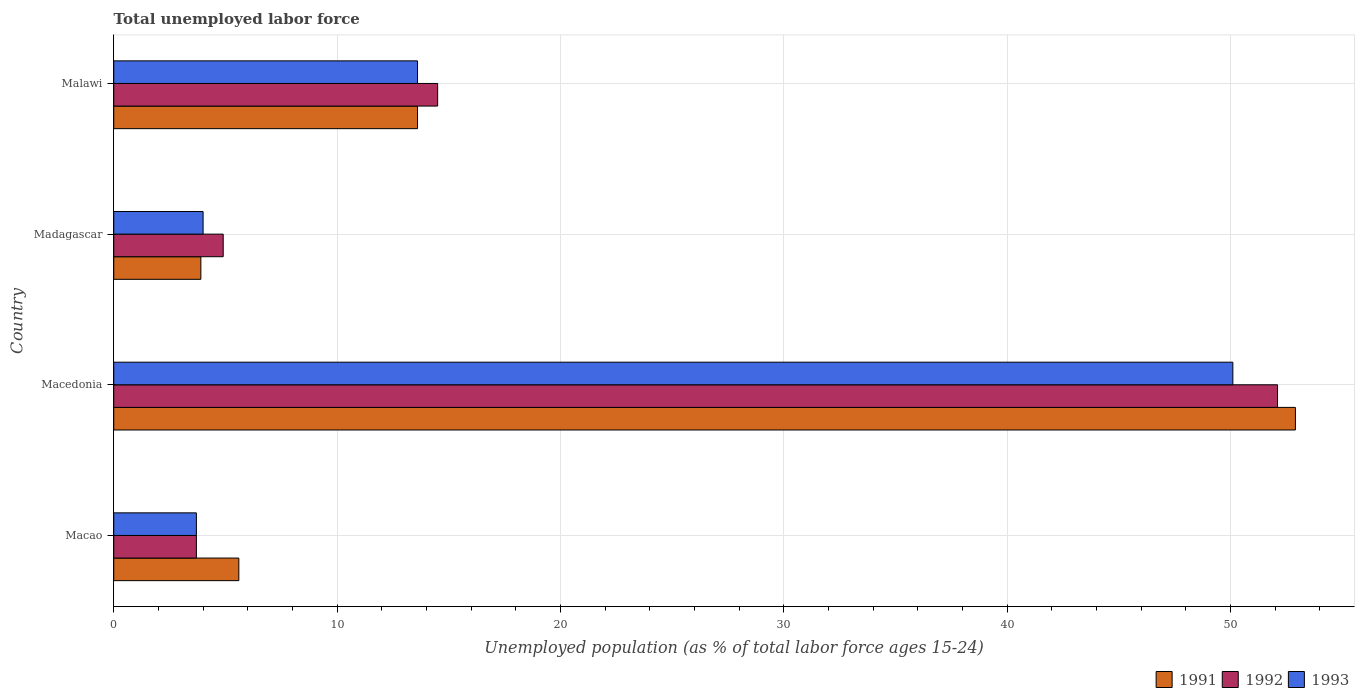How many groups of bars are there?
Provide a short and direct response. 4. Are the number of bars on each tick of the Y-axis equal?
Give a very brief answer. Yes. How many bars are there on the 2nd tick from the top?
Give a very brief answer. 3. What is the label of the 4th group of bars from the top?
Your answer should be very brief. Macao. What is the percentage of unemployed population in in 1993 in Madagascar?
Ensure brevity in your answer.  4. Across all countries, what is the maximum percentage of unemployed population in in 1991?
Give a very brief answer. 52.9. Across all countries, what is the minimum percentage of unemployed population in in 1993?
Give a very brief answer. 3.7. In which country was the percentage of unemployed population in in 1992 maximum?
Ensure brevity in your answer.  Macedonia. In which country was the percentage of unemployed population in in 1993 minimum?
Give a very brief answer. Macao. What is the total percentage of unemployed population in in 1992 in the graph?
Your response must be concise. 75.2. What is the difference between the percentage of unemployed population in in 1991 in Macao and that in Madagascar?
Your response must be concise. 1.7. What is the difference between the percentage of unemployed population in in 1991 in Macao and the percentage of unemployed population in in 1993 in Malawi?
Your answer should be very brief. -8. What is the average percentage of unemployed population in in 1992 per country?
Keep it short and to the point. 18.8. What is the difference between the percentage of unemployed population in in 1991 and percentage of unemployed population in in 1992 in Madagascar?
Provide a succinct answer. -1. In how many countries, is the percentage of unemployed population in in 1992 greater than 12 %?
Your answer should be very brief. 2. What is the ratio of the percentage of unemployed population in in 1993 in Macao to that in Macedonia?
Provide a succinct answer. 0.07. Is the percentage of unemployed population in in 1991 in Madagascar less than that in Malawi?
Offer a very short reply. Yes. Is the difference between the percentage of unemployed population in in 1991 in Madagascar and Malawi greater than the difference between the percentage of unemployed population in in 1992 in Madagascar and Malawi?
Your answer should be very brief. No. What is the difference between the highest and the second highest percentage of unemployed population in in 1993?
Your response must be concise. 36.5. What is the difference between the highest and the lowest percentage of unemployed population in in 1991?
Ensure brevity in your answer.  49. What does the 2nd bar from the top in Malawi represents?
Offer a very short reply. 1992. How many bars are there?
Ensure brevity in your answer.  12. How many countries are there in the graph?
Ensure brevity in your answer.  4. Are the values on the major ticks of X-axis written in scientific E-notation?
Your answer should be very brief. No. What is the title of the graph?
Offer a terse response. Total unemployed labor force. Does "2013" appear as one of the legend labels in the graph?
Offer a terse response. No. What is the label or title of the X-axis?
Make the answer very short. Unemployed population (as % of total labor force ages 15-24). What is the label or title of the Y-axis?
Keep it short and to the point. Country. What is the Unemployed population (as % of total labor force ages 15-24) in 1991 in Macao?
Ensure brevity in your answer.  5.6. What is the Unemployed population (as % of total labor force ages 15-24) in 1992 in Macao?
Your answer should be compact. 3.7. What is the Unemployed population (as % of total labor force ages 15-24) in 1993 in Macao?
Give a very brief answer. 3.7. What is the Unemployed population (as % of total labor force ages 15-24) of 1991 in Macedonia?
Make the answer very short. 52.9. What is the Unemployed population (as % of total labor force ages 15-24) of 1992 in Macedonia?
Keep it short and to the point. 52.1. What is the Unemployed population (as % of total labor force ages 15-24) of 1993 in Macedonia?
Your answer should be compact. 50.1. What is the Unemployed population (as % of total labor force ages 15-24) of 1991 in Madagascar?
Offer a terse response. 3.9. What is the Unemployed population (as % of total labor force ages 15-24) in 1992 in Madagascar?
Provide a succinct answer. 4.9. What is the Unemployed population (as % of total labor force ages 15-24) of 1991 in Malawi?
Your answer should be very brief. 13.6. What is the Unemployed population (as % of total labor force ages 15-24) in 1992 in Malawi?
Provide a short and direct response. 14.5. What is the Unemployed population (as % of total labor force ages 15-24) of 1993 in Malawi?
Provide a succinct answer. 13.6. Across all countries, what is the maximum Unemployed population (as % of total labor force ages 15-24) of 1991?
Your response must be concise. 52.9. Across all countries, what is the maximum Unemployed population (as % of total labor force ages 15-24) in 1992?
Provide a short and direct response. 52.1. Across all countries, what is the maximum Unemployed population (as % of total labor force ages 15-24) in 1993?
Give a very brief answer. 50.1. Across all countries, what is the minimum Unemployed population (as % of total labor force ages 15-24) in 1991?
Offer a terse response. 3.9. Across all countries, what is the minimum Unemployed population (as % of total labor force ages 15-24) in 1992?
Make the answer very short. 3.7. Across all countries, what is the minimum Unemployed population (as % of total labor force ages 15-24) in 1993?
Make the answer very short. 3.7. What is the total Unemployed population (as % of total labor force ages 15-24) in 1991 in the graph?
Give a very brief answer. 76. What is the total Unemployed population (as % of total labor force ages 15-24) of 1992 in the graph?
Keep it short and to the point. 75.2. What is the total Unemployed population (as % of total labor force ages 15-24) of 1993 in the graph?
Ensure brevity in your answer.  71.4. What is the difference between the Unemployed population (as % of total labor force ages 15-24) in 1991 in Macao and that in Macedonia?
Give a very brief answer. -47.3. What is the difference between the Unemployed population (as % of total labor force ages 15-24) of 1992 in Macao and that in Macedonia?
Your answer should be very brief. -48.4. What is the difference between the Unemployed population (as % of total labor force ages 15-24) of 1993 in Macao and that in Macedonia?
Keep it short and to the point. -46.4. What is the difference between the Unemployed population (as % of total labor force ages 15-24) of 1991 in Macedonia and that in Madagascar?
Make the answer very short. 49. What is the difference between the Unemployed population (as % of total labor force ages 15-24) in 1992 in Macedonia and that in Madagascar?
Give a very brief answer. 47.2. What is the difference between the Unemployed population (as % of total labor force ages 15-24) in 1993 in Macedonia and that in Madagascar?
Offer a very short reply. 46.1. What is the difference between the Unemployed population (as % of total labor force ages 15-24) of 1991 in Macedonia and that in Malawi?
Give a very brief answer. 39.3. What is the difference between the Unemployed population (as % of total labor force ages 15-24) of 1992 in Macedonia and that in Malawi?
Ensure brevity in your answer.  37.6. What is the difference between the Unemployed population (as % of total labor force ages 15-24) in 1993 in Macedonia and that in Malawi?
Your answer should be compact. 36.5. What is the difference between the Unemployed population (as % of total labor force ages 15-24) in 1991 in Madagascar and that in Malawi?
Offer a very short reply. -9.7. What is the difference between the Unemployed population (as % of total labor force ages 15-24) in 1993 in Madagascar and that in Malawi?
Your response must be concise. -9.6. What is the difference between the Unemployed population (as % of total labor force ages 15-24) of 1991 in Macao and the Unemployed population (as % of total labor force ages 15-24) of 1992 in Macedonia?
Offer a terse response. -46.5. What is the difference between the Unemployed population (as % of total labor force ages 15-24) in 1991 in Macao and the Unemployed population (as % of total labor force ages 15-24) in 1993 in Macedonia?
Provide a short and direct response. -44.5. What is the difference between the Unemployed population (as % of total labor force ages 15-24) in 1992 in Macao and the Unemployed population (as % of total labor force ages 15-24) in 1993 in Macedonia?
Offer a very short reply. -46.4. What is the difference between the Unemployed population (as % of total labor force ages 15-24) in 1991 in Macao and the Unemployed population (as % of total labor force ages 15-24) in 1992 in Malawi?
Your answer should be very brief. -8.9. What is the difference between the Unemployed population (as % of total labor force ages 15-24) in 1991 in Macedonia and the Unemployed population (as % of total labor force ages 15-24) in 1993 in Madagascar?
Keep it short and to the point. 48.9. What is the difference between the Unemployed population (as % of total labor force ages 15-24) in 1992 in Macedonia and the Unemployed population (as % of total labor force ages 15-24) in 1993 in Madagascar?
Provide a short and direct response. 48.1. What is the difference between the Unemployed population (as % of total labor force ages 15-24) of 1991 in Macedonia and the Unemployed population (as % of total labor force ages 15-24) of 1992 in Malawi?
Your answer should be very brief. 38.4. What is the difference between the Unemployed population (as % of total labor force ages 15-24) of 1991 in Macedonia and the Unemployed population (as % of total labor force ages 15-24) of 1993 in Malawi?
Offer a terse response. 39.3. What is the difference between the Unemployed population (as % of total labor force ages 15-24) of 1992 in Macedonia and the Unemployed population (as % of total labor force ages 15-24) of 1993 in Malawi?
Your response must be concise. 38.5. What is the difference between the Unemployed population (as % of total labor force ages 15-24) in 1991 in Madagascar and the Unemployed population (as % of total labor force ages 15-24) in 1993 in Malawi?
Make the answer very short. -9.7. What is the average Unemployed population (as % of total labor force ages 15-24) of 1992 per country?
Keep it short and to the point. 18.8. What is the average Unemployed population (as % of total labor force ages 15-24) in 1993 per country?
Keep it short and to the point. 17.85. What is the difference between the Unemployed population (as % of total labor force ages 15-24) in 1992 and Unemployed population (as % of total labor force ages 15-24) in 1993 in Macao?
Provide a short and direct response. 0. What is the difference between the Unemployed population (as % of total labor force ages 15-24) in 1991 and Unemployed population (as % of total labor force ages 15-24) in 1992 in Macedonia?
Keep it short and to the point. 0.8. What is the difference between the Unemployed population (as % of total labor force ages 15-24) of 1991 and Unemployed population (as % of total labor force ages 15-24) of 1993 in Macedonia?
Your answer should be compact. 2.8. What is the difference between the Unemployed population (as % of total labor force ages 15-24) of 1991 and Unemployed population (as % of total labor force ages 15-24) of 1993 in Madagascar?
Give a very brief answer. -0.1. What is the difference between the Unemployed population (as % of total labor force ages 15-24) of 1992 and Unemployed population (as % of total labor force ages 15-24) of 1993 in Malawi?
Keep it short and to the point. 0.9. What is the ratio of the Unemployed population (as % of total labor force ages 15-24) in 1991 in Macao to that in Macedonia?
Offer a terse response. 0.11. What is the ratio of the Unemployed population (as % of total labor force ages 15-24) in 1992 in Macao to that in Macedonia?
Give a very brief answer. 0.07. What is the ratio of the Unemployed population (as % of total labor force ages 15-24) of 1993 in Macao to that in Macedonia?
Ensure brevity in your answer.  0.07. What is the ratio of the Unemployed population (as % of total labor force ages 15-24) of 1991 in Macao to that in Madagascar?
Make the answer very short. 1.44. What is the ratio of the Unemployed population (as % of total labor force ages 15-24) of 1992 in Macao to that in Madagascar?
Provide a short and direct response. 0.76. What is the ratio of the Unemployed population (as % of total labor force ages 15-24) of 1993 in Macao to that in Madagascar?
Ensure brevity in your answer.  0.93. What is the ratio of the Unemployed population (as % of total labor force ages 15-24) in 1991 in Macao to that in Malawi?
Your answer should be very brief. 0.41. What is the ratio of the Unemployed population (as % of total labor force ages 15-24) of 1992 in Macao to that in Malawi?
Make the answer very short. 0.26. What is the ratio of the Unemployed population (as % of total labor force ages 15-24) of 1993 in Macao to that in Malawi?
Your response must be concise. 0.27. What is the ratio of the Unemployed population (as % of total labor force ages 15-24) of 1991 in Macedonia to that in Madagascar?
Offer a terse response. 13.56. What is the ratio of the Unemployed population (as % of total labor force ages 15-24) of 1992 in Macedonia to that in Madagascar?
Provide a short and direct response. 10.63. What is the ratio of the Unemployed population (as % of total labor force ages 15-24) of 1993 in Macedonia to that in Madagascar?
Ensure brevity in your answer.  12.53. What is the ratio of the Unemployed population (as % of total labor force ages 15-24) of 1991 in Macedonia to that in Malawi?
Make the answer very short. 3.89. What is the ratio of the Unemployed population (as % of total labor force ages 15-24) of 1992 in Macedonia to that in Malawi?
Give a very brief answer. 3.59. What is the ratio of the Unemployed population (as % of total labor force ages 15-24) in 1993 in Macedonia to that in Malawi?
Offer a terse response. 3.68. What is the ratio of the Unemployed population (as % of total labor force ages 15-24) in 1991 in Madagascar to that in Malawi?
Your response must be concise. 0.29. What is the ratio of the Unemployed population (as % of total labor force ages 15-24) of 1992 in Madagascar to that in Malawi?
Ensure brevity in your answer.  0.34. What is the ratio of the Unemployed population (as % of total labor force ages 15-24) in 1993 in Madagascar to that in Malawi?
Provide a succinct answer. 0.29. What is the difference between the highest and the second highest Unemployed population (as % of total labor force ages 15-24) in 1991?
Your answer should be compact. 39.3. What is the difference between the highest and the second highest Unemployed population (as % of total labor force ages 15-24) in 1992?
Offer a very short reply. 37.6. What is the difference between the highest and the second highest Unemployed population (as % of total labor force ages 15-24) of 1993?
Provide a short and direct response. 36.5. What is the difference between the highest and the lowest Unemployed population (as % of total labor force ages 15-24) of 1991?
Give a very brief answer. 49. What is the difference between the highest and the lowest Unemployed population (as % of total labor force ages 15-24) of 1992?
Ensure brevity in your answer.  48.4. What is the difference between the highest and the lowest Unemployed population (as % of total labor force ages 15-24) of 1993?
Provide a short and direct response. 46.4. 